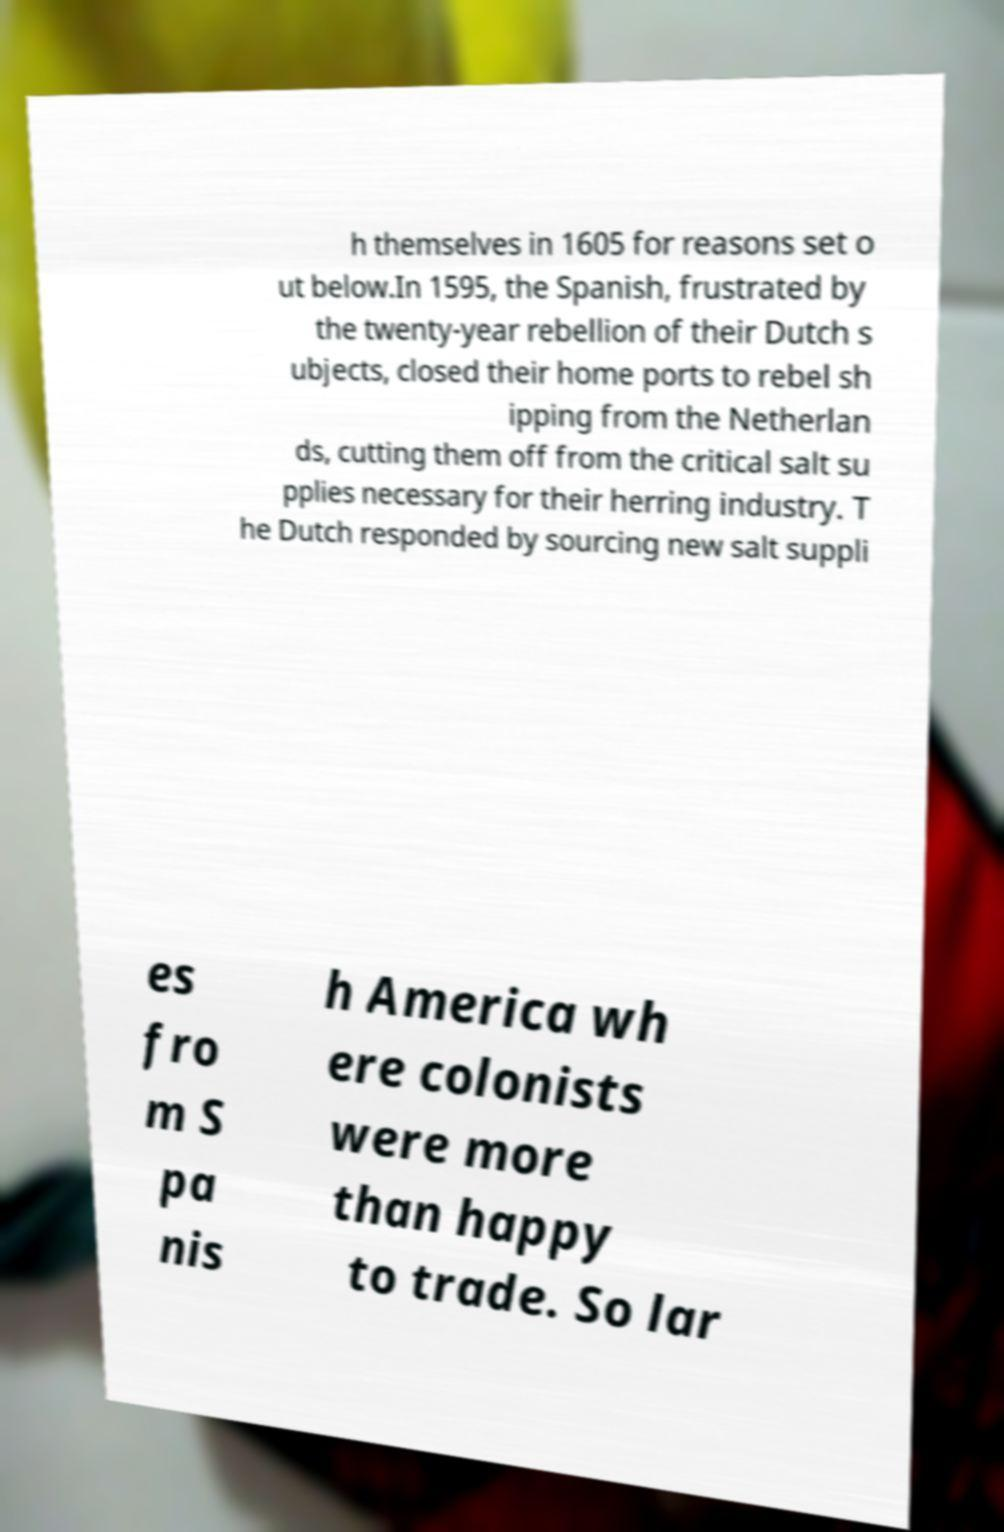For documentation purposes, I need the text within this image transcribed. Could you provide that? h themselves in 1605 for reasons set o ut below.In 1595, the Spanish, frustrated by the twenty-year rebellion of their Dutch s ubjects, closed their home ports to rebel sh ipping from the Netherlan ds, cutting them off from the critical salt su pplies necessary for their herring industry. T he Dutch responded by sourcing new salt suppli es fro m S pa nis h America wh ere colonists were more than happy to trade. So lar 